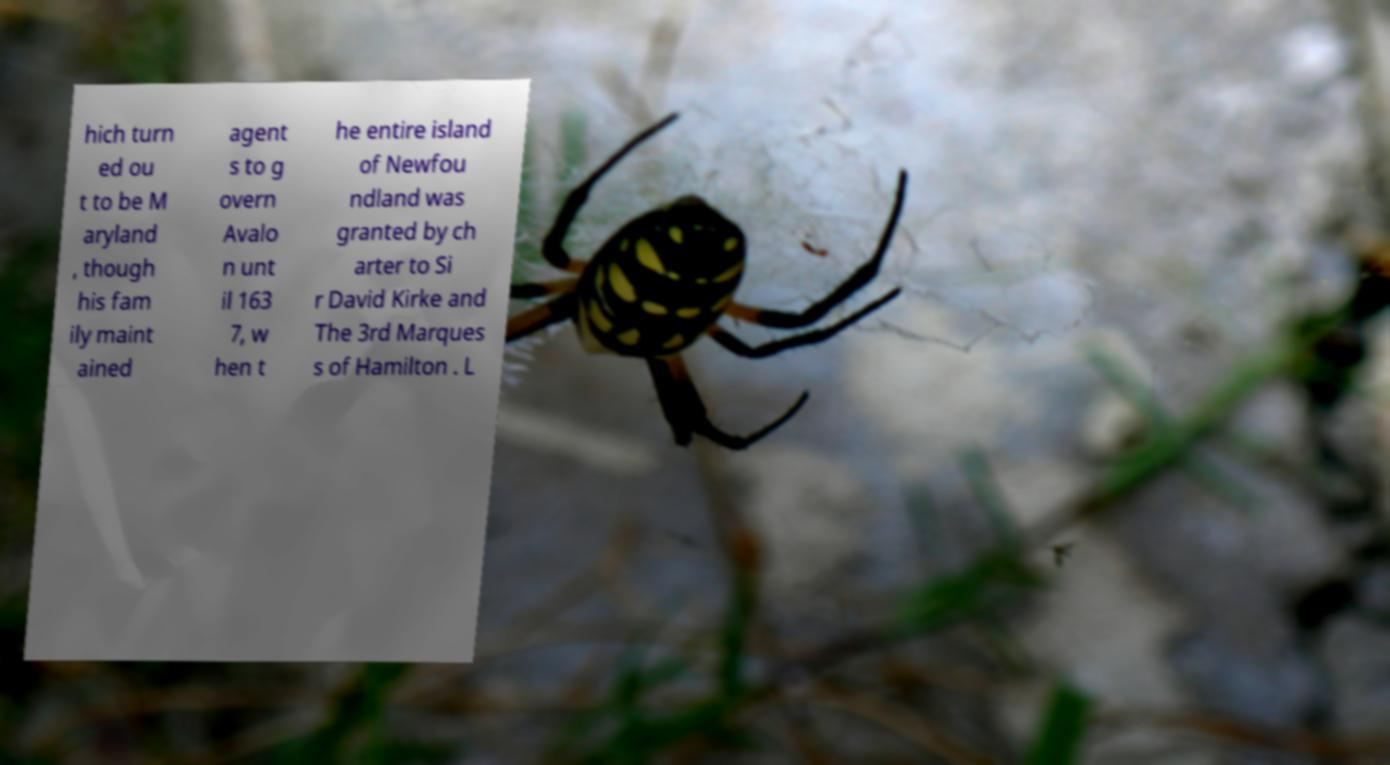Can you read and provide the text displayed in the image?This photo seems to have some interesting text. Can you extract and type it out for me? hich turn ed ou t to be M aryland , though his fam ily maint ained agent s to g overn Avalo n unt il 163 7, w hen t he entire island of Newfou ndland was granted by ch arter to Si r David Kirke and The 3rd Marques s of Hamilton . L 